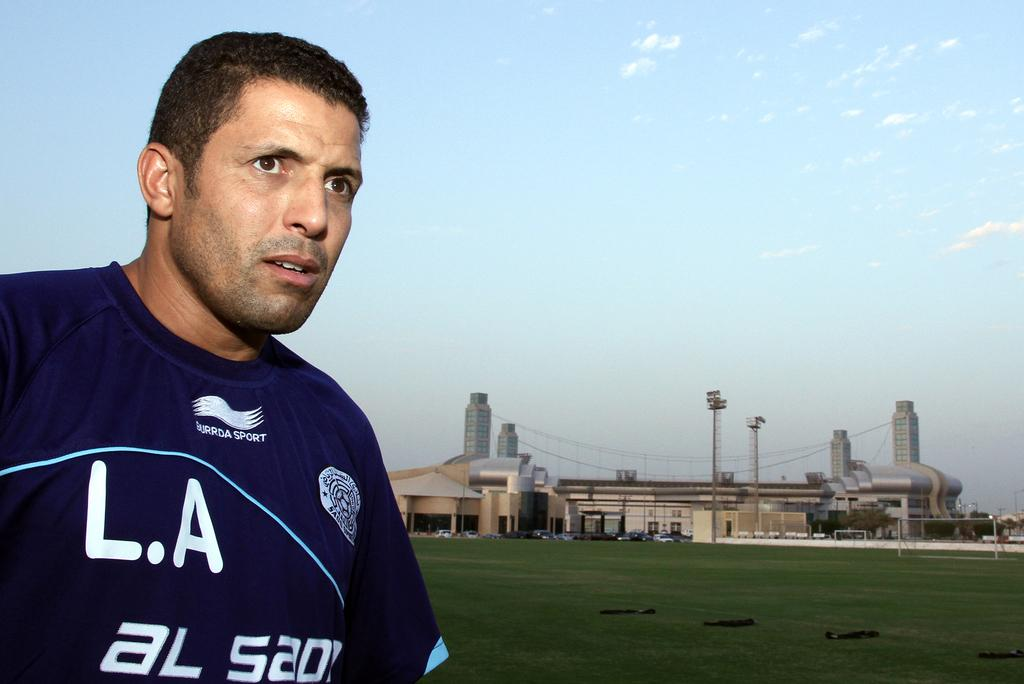<image>
Offer a succinct explanation of the picture presented. a person in a LA AL 520 jersey looking over a field 